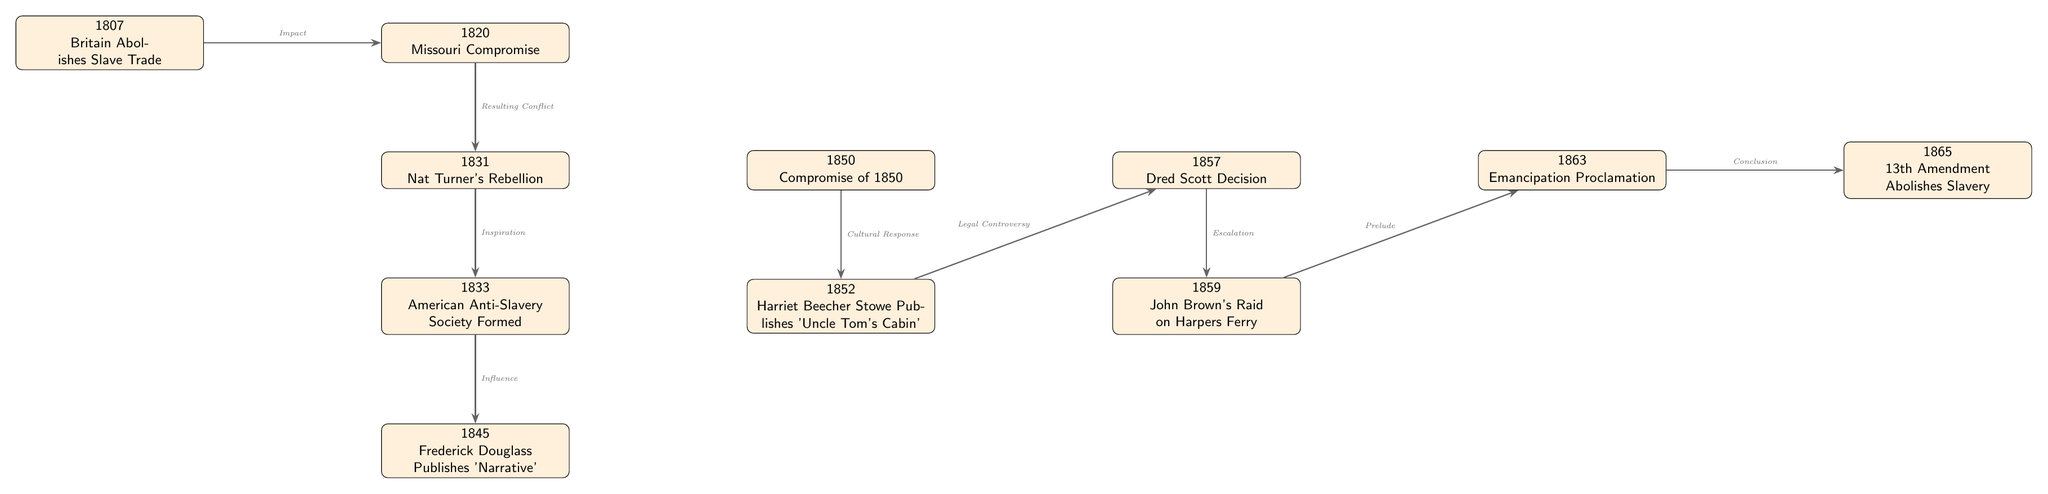What event occurred in 1833? The diagram shows that the event in 1833 is the formation of the American Anti-Slavery Society. This information is retrieved directly from the node labeled "1833."
Answer: American Anti-Slavery Society Formed How many events are listed in the timeline? By counting the number of nodes in the diagram, there are a total of 10 significant events. Each event is represented by a distinct node.
Answer: 10 What is the relationship between the events of 1850 and 1852? The diagram indicates that there is a connection labeled "Cultural Response" that points from the 1850 event (Compromise of 1850) to the 1852 event (Harriet Beecher Stowe Publishes 'Uncle Tom's Cabin'). This shows that one influenced the other.
Answer: Cultural Response Which event directly follows the Dred Scott Decision in 1857? The diagram indicates that the event that directly follows the Dred Scott Decision is John Brown's Raid on Harpers Ferry, as it is positioned directly below the 1857 event in the diagram.
Answer: John Brown's Raid on Harpers Ferry What prompted the American Anti-Slavery Society formation in 1833? The diagram shows that the American Anti-Slavery Society was influenced by Nat Turner's Rebellion in 1831, indicating that this earlier event inspired the creation of the abolitionist organization.
Answer: Nat Turner's Rebellion What event is identified as the "Prelude" to the Emancipation Proclamation? According to the diagram, John Brown's Raid on Harpers Ferry (1859) is labeled as the "Prelude" to the Emancipation Proclamation that occurred in 1863, indicating a sequence of influence.
Answer: John Brown's Raid on Harpers Ferry Which event signifies the end of slavery in the timeline? The last event labeled in the timeline is the 13th Amendment Abolishes Slavery in 1865, which denotes the conclusion of slavery as per the diagram's representation.
Answer: 13th Amendment Abolishes Slavery Which event is cited for its legal controversy in 1857? The diagram states that the Dred Scott Decision, which occurred in 1857, is directly linked to "Legal Controversy," indicating it was a significant event regarding the legal issues surrounding slavery.
Answer: Dred Scott Decision 